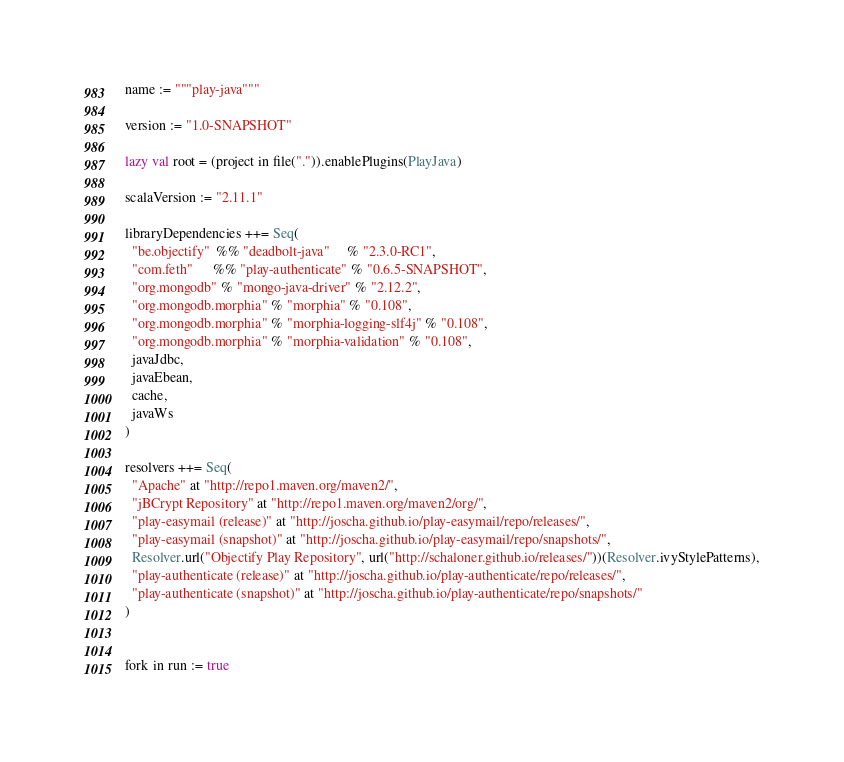Convert code to text. <code><loc_0><loc_0><loc_500><loc_500><_Scala_>name := """play-java"""

version := "1.0-SNAPSHOT"

lazy val root = (project in file(".")).enablePlugins(PlayJava)

scalaVersion := "2.11.1"

libraryDependencies ++= Seq(
  "be.objectify"  %% "deadbolt-java"     % "2.3.0-RC1",
  "com.feth"      %% "play-authenticate" % "0.6.5-SNAPSHOT",
  "org.mongodb" % "mongo-java-driver" % "2.12.2",
  "org.mongodb.morphia" % "morphia" % "0.108",
  "org.mongodb.morphia" % "morphia-logging-slf4j" % "0.108",
  "org.mongodb.morphia" % "morphia-validation" % "0.108",
  javaJdbc,
  javaEbean,
  cache,
  javaWs
)

resolvers ++= Seq(
  "Apache" at "http://repo1.maven.org/maven2/",
  "jBCrypt Repository" at "http://repo1.maven.org/maven2/org/",
  "play-easymail (release)" at "http://joscha.github.io/play-easymail/repo/releases/",
  "play-easymail (snapshot)" at "http://joscha.github.io/play-easymail/repo/snapshots/",
  Resolver.url("Objectify Play Repository", url("http://schaloner.github.io/releases/"))(Resolver.ivyStylePatterns),
  "play-authenticate (release)" at "http://joscha.github.io/play-authenticate/repo/releases/",
  "play-authenticate (snapshot)" at "http://joscha.github.io/play-authenticate/repo/snapshots/"
)


fork in run := true</code> 